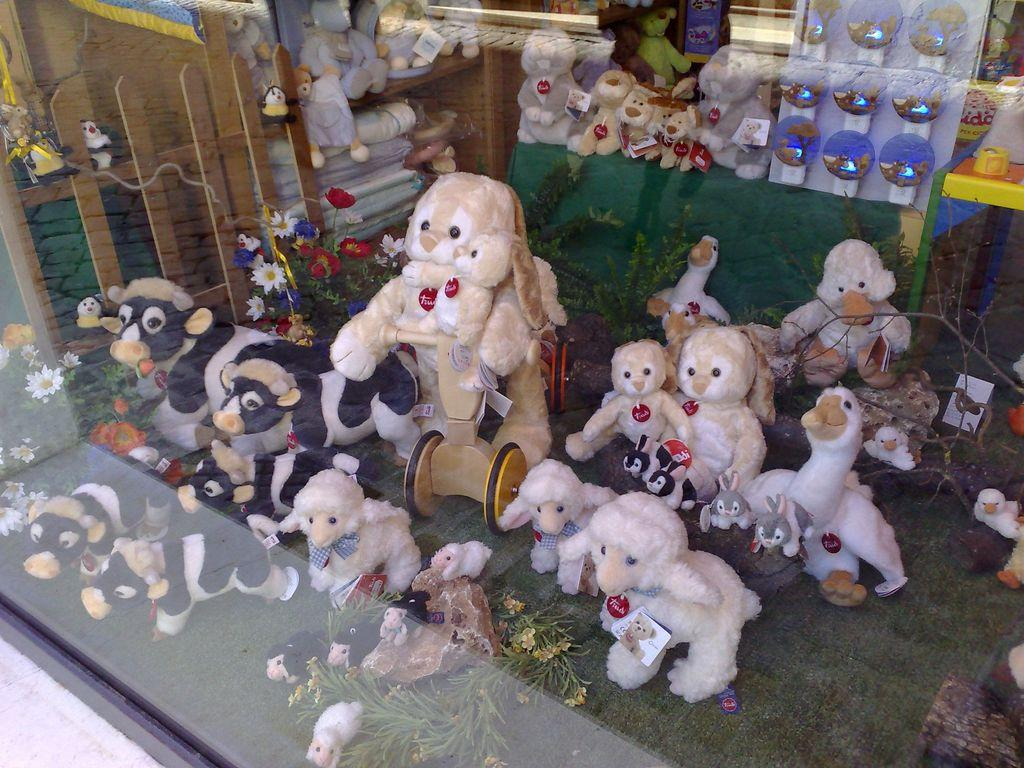What type of toys are present in the image? There are soft toys in the image. Can you describe the specific animals represented by the soft toys? The soft toys include rabbits, cows, sheep, and ducks. How many people are in the crowd surrounding the soft toys in the image? There is no crowd present in the image; it only features soft toys. 